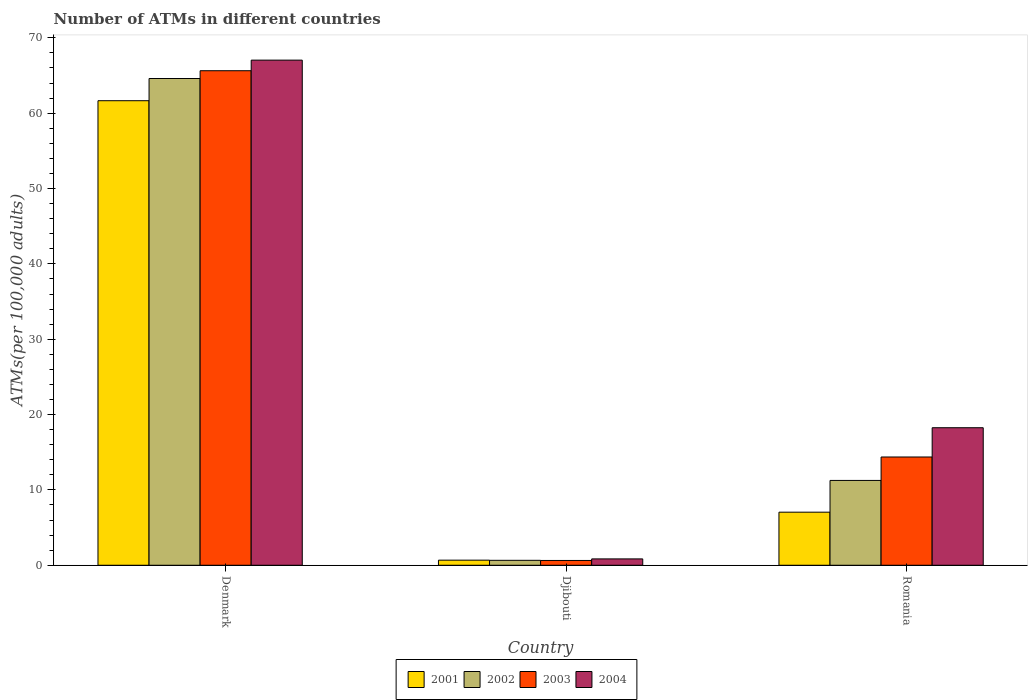Are the number of bars per tick equal to the number of legend labels?
Offer a terse response. Yes. How many bars are there on the 1st tick from the left?
Provide a succinct answer. 4. In how many cases, is the number of bars for a given country not equal to the number of legend labels?
Provide a succinct answer. 0. What is the number of ATMs in 2001 in Romania?
Offer a terse response. 7.04. Across all countries, what is the maximum number of ATMs in 2002?
Keep it short and to the point. 64.61. Across all countries, what is the minimum number of ATMs in 2004?
Give a very brief answer. 0.84. In which country was the number of ATMs in 2002 minimum?
Your answer should be very brief. Djibouti. What is the total number of ATMs in 2004 in the graph?
Give a very brief answer. 86.14. What is the difference between the number of ATMs in 2004 in Denmark and that in Romania?
Ensure brevity in your answer.  48.79. What is the difference between the number of ATMs in 2002 in Djibouti and the number of ATMs in 2001 in Denmark?
Provide a succinct answer. -61. What is the average number of ATMs in 2001 per country?
Your answer should be compact. 23.13. What is the difference between the number of ATMs of/in 2004 and number of ATMs of/in 2002 in Romania?
Offer a terse response. 7. In how many countries, is the number of ATMs in 2001 greater than 24?
Your response must be concise. 1. What is the ratio of the number of ATMs in 2002 in Djibouti to that in Romania?
Your response must be concise. 0.06. Is the number of ATMs in 2002 in Denmark less than that in Romania?
Keep it short and to the point. No. Is the difference between the number of ATMs in 2004 in Denmark and Djibouti greater than the difference between the number of ATMs in 2002 in Denmark and Djibouti?
Offer a terse response. Yes. What is the difference between the highest and the second highest number of ATMs in 2001?
Provide a succinct answer. -60.98. What is the difference between the highest and the lowest number of ATMs in 2002?
Ensure brevity in your answer.  63.95. In how many countries, is the number of ATMs in 2004 greater than the average number of ATMs in 2004 taken over all countries?
Ensure brevity in your answer.  1. Is the sum of the number of ATMs in 2001 in Djibouti and Romania greater than the maximum number of ATMs in 2004 across all countries?
Ensure brevity in your answer.  No. Is it the case that in every country, the sum of the number of ATMs in 2003 and number of ATMs in 2004 is greater than the number of ATMs in 2002?
Ensure brevity in your answer.  Yes. How many bars are there?
Your answer should be compact. 12. Are all the bars in the graph horizontal?
Keep it short and to the point. No. Does the graph contain grids?
Offer a terse response. No. How many legend labels are there?
Offer a terse response. 4. How are the legend labels stacked?
Make the answer very short. Horizontal. What is the title of the graph?
Your answer should be very brief. Number of ATMs in different countries. What is the label or title of the X-axis?
Keep it short and to the point. Country. What is the label or title of the Y-axis?
Your response must be concise. ATMs(per 100,0 adults). What is the ATMs(per 100,000 adults) of 2001 in Denmark?
Your answer should be very brief. 61.66. What is the ATMs(per 100,000 adults) in 2002 in Denmark?
Provide a succinct answer. 64.61. What is the ATMs(per 100,000 adults) of 2003 in Denmark?
Give a very brief answer. 65.64. What is the ATMs(per 100,000 adults) in 2004 in Denmark?
Give a very brief answer. 67.04. What is the ATMs(per 100,000 adults) of 2001 in Djibouti?
Your answer should be very brief. 0.68. What is the ATMs(per 100,000 adults) of 2002 in Djibouti?
Provide a succinct answer. 0.66. What is the ATMs(per 100,000 adults) in 2003 in Djibouti?
Keep it short and to the point. 0.64. What is the ATMs(per 100,000 adults) of 2004 in Djibouti?
Provide a succinct answer. 0.84. What is the ATMs(per 100,000 adults) of 2001 in Romania?
Provide a short and direct response. 7.04. What is the ATMs(per 100,000 adults) in 2002 in Romania?
Ensure brevity in your answer.  11.26. What is the ATMs(per 100,000 adults) of 2003 in Romania?
Your response must be concise. 14.37. What is the ATMs(per 100,000 adults) in 2004 in Romania?
Ensure brevity in your answer.  18.26. Across all countries, what is the maximum ATMs(per 100,000 adults) in 2001?
Your response must be concise. 61.66. Across all countries, what is the maximum ATMs(per 100,000 adults) of 2002?
Ensure brevity in your answer.  64.61. Across all countries, what is the maximum ATMs(per 100,000 adults) in 2003?
Make the answer very short. 65.64. Across all countries, what is the maximum ATMs(per 100,000 adults) of 2004?
Keep it short and to the point. 67.04. Across all countries, what is the minimum ATMs(per 100,000 adults) in 2001?
Offer a very short reply. 0.68. Across all countries, what is the minimum ATMs(per 100,000 adults) in 2002?
Provide a short and direct response. 0.66. Across all countries, what is the minimum ATMs(per 100,000 adults) in 2003?
Give a very brief answer. 0.64. Across all countries, what is the minimum ATMs(per 100,000 adults) in 2004?
Ensure brevity in your answer.  0.84. What is the total ATMs(per 100,000 adults) of 2001 in the graph?
Provide a succinct answer. 69.38. What is the total ATMs(per 100,000 adults) of 2002 in the graph?
Offer a very short reply. 76.52. What is the total ATMs(per 100,000 adults) in 2003 in the graph?
Make the answer very short. 80.65. What is the total ATMs(per 100,000 adults) in 2004 in the graph?
Provide a succinct answer. 86.14. What is the difference between the ATMs(per 100,000 adults) of 2001 in Denmark and that in Djibouti?
Offer a terse response. 60.98. What is the difference between the ATMs(per 100,000 adults) of 2002 in Denmark and that in Djibouti?
Offer a terse response. 63.95. What is the difference between the ATMs(per 100,000 adults) of 2003 in Denmark and that in Djibouti?
Give a very brief answer. 65. What is the difference between the ATMs(per 100,000 adults) in 2004 in Denmark and that in Djibouti?
Offer a terse response. 66.2. What is the difference between the ATMs(per 100,000 adults) of 2001 in Denmark and that in Romania?
Give a very brief answer. 54.61. What is the difference between the ATMs(per 100,000 adults) in 2002 in Denmark and that in Romania?
Give a very brief answer. 53.35. What is the difference between the ATMs(per 100,000 adults) in 2003 in Denmark and that in Romania?
Provide a short and direct response. 51.27. What is the difference between the ATMs(per 100,000 adults) of 2004 in Denmark and that in Romania?
Ensure brevity in your answer.  48.79. What is the difference between the ATMs(per 100,000 adults) of 2001 in Djibouti and that in Romania?
Give a very brief answer. -6.37. What is the difference between the ATMs(per 100,000 adults) of 2002 in Djibouti and that in Romania?
Provide a succinct answer. -10.6. What is the difference between the ATMs(per 100,000 adults) in 2003 in Djibouti and that in Romania?
Provide a succinct answer. -13.73. What is the difference between the ATMs(per 100,000 adults) of 2004 in Djibouti and that in Romania?
Your answer should be compact. -17.41. What is the difference between the ATMs(per 100,000 adults) in 2001 in Denmark and the ATMs(per 100,000 adults) in 2002 in Djibouti?
Your answer should be very brief. 61. What is the difference between the ATMs(per 100,000 adults) in 2001 in Denmark and the ATMs(per 100,000 adults) in 2003 in Djibouti?
Provide a short and direct response. 61.02. What is the difference between the ATMs(per 100,000 adults) in 2001 in Denmark and the ATMs(per 100,000 adults) in 2004 in Djibouti?
Provide a succinct answer. 60.81. What is the difference between the ATMs(per 100,000 adults) in 2002 in Denmark and the ATMs(per 100,000 adults) in 2003 in Djibouti?
Your answer should be very brief. 63.97. What is the difference between the ATMs(per 100,000 adults) of 2002 in Denmark and the ATMs(per 100,000 adults) of 2004 in Djibouti?
Offer a terse response. 63.76. What is the difference between the ATMs(per 100,000 adults) of 2003 in Denmark and the ATMs(per 100,000 adults) of 2004 in Djibouti?
Provide a succinct answer. 64.79. What is the difference between the ATMs(per 100,000 adults) of 2001 in Denmark and the ATMs(per 100,000 adults) of 2002 in Romania?
Your response must be concise. 50.4. What is the difference between the ATMs(per 100,000 adults) in 2001 in Denmark and the ATMs(per 100,000 adults) in 2003 in Romania?
Keep it short and to the point. 47.29. What is the difference between the ATMs(per 100,000 adults) in 2001 in Denmark and the ATMs(per 100,000 adults) in 2004 in Romania?
Make the answer very short. 43.4. What is the difference between the ATMs(per 100,000 adults) of 2002 in Denmark and the ATMs(per 100,000 adults) of 2003 in Romania?
Your response must be concise. 50.24. What is the difference between the ATMs(per 100,000 adults) in 2002 in Denmark and the ATMs(per 100,000 adults) in 2004 in Romania?
Provide a short and direct response. 46.35. What is the difference between the ATMs(per 100,000 adults) in 2003 in Denmark and the ATMs(per 100,000 adults) in 2004 in Romania?
Provide a short and direct response. 47.38. What is the difference between the ATMs(per 100,000 adults) of 2001 in Djibouti and the ATMs(per 100,000 adults) of 2002 in Romania?
Provide a succinct answer. -10.58. What is the difference between the ATMs(per 100,000 adults) in 2001 in Djibouti and the ATMs(per 100,000 adults) in 2003 in Romania?
Offer a terse response. -13.69. What is the difference between the ATMs(per 100,000 adults) in 2001 in Djibouti and the ATMs(per 100,000 adults) in 2004 in Romania?
Ensure brevity in your answer.  -17.58. What is the difference between the ATMs(per 100,000 adults) of 2002 in Djibouti and the ATMs(per 100,000 adults) of 2003 in Romania?
Keep it short and to the point. -13.71. What is the difference between the ATMs(per 100,000 adults) of 2002 in Djibouti and the ATMs(per 100,000 adults) of 2004 in Romania?
Give a very brief answer. -17.6. What is the difference between the ATMs(per 100,000 adults) of 2003 in Djibouti and the ATMs(per 100,000 adults) of 2004 in Romania?
Provide a succinct answer. -17.62. What is the average ATMs(per 100,000 adults) in 2001 per country?
Offer a very short reply. 23.13. What is the average ATMs(per 100,000 adults) in 2002 per country?
Offer a very short reply. 25.51. What is the average ATMs(per 100,000 adults) of 2003 per country?
Your response must be concise. 26.88. What is the average ATMs(per 100,000 adults) in 2004 per country?
Your response must be concise. 28.71. What is the difference between the ATMs(per 100,000 adults) of 2001 and ATMs(per 100,000 adults) of 2002 in Denmark?
Provide a succinct answer. -2.95. What is the difference between the ATMs(per 100,000 adults) of 2001 and ATMs(per 100,000 adults) of 2003 in Denmark?
Give a very brief answer. -3.98. What is the difference between the ATMs(per 100,000 adults) of 2001 and ATMs(per 100,000 adults) of 2004 in Denmark?
Your response must be concise. -5.39. What is the difference between the ATMs(per 100,000 adults) in 2002 and ATMs(per 100,000 adults) in 2003 in Denmark?
Make the answer very short. -1.03. What is the difference between the ATMs(per 100,000 adults) in 2002 and ATMs(per 100,000 adults) in 2004 in Denmark?
Offer a terse response. -2.44. What is the difference between the ATMs(per 100,000 adults) in 2003 and ATMs(per 100,000 adults) in 2004 in Denmark?
Offer a terse response. -1.41. What is the difference between the ATMs(per 100,000 adults) in 2001 and ATMs(per 100,000 adults) in 2002 in Djibouti?
Provide a succinct answer. 0.02. What is the difference between the ATMs(per 100,000 adults) in 2001 and ATMs(per 100,000 adults) in 2003 in Djibouti?
Your response must be concise. 0.04. What is the difference between the ATMs(per 100,000 adults) in 2001 and ATMs(per 100,000 adults) in 2004 in Djibouti?
Your answer should be compact. -0.17. What is the difference between the ATMs(per 100,000 adults) of 2002 and ATMs(per 100,000 adults) of 2003 in Djibouti?
Give a very brief answer. 0.02. What is the difference between the ATMs(per 100,000 adults) of 2002 and ATMs(per 100,000 adults) of 2004 in Djibouti?
Offer a very short reply. -0.19. What is the difference between the ATMs(per 100,000 adults) of 2003 and ATMs(per 100,000 adults) of 2004 in Djibouti?
Provide a short and direct response. -0.21. What is the difference between the ATMs(per 100,000 adults) in 2001 and ATMs(per 100,000 adults) in 2002 in Romania?
Give a very brief answer. -4.21. What is the difference between the ATMs(per 100,000 adults) in 2001 and ATMs(per 100,000 adults) in 2003 in Romania?
Give a very brief answer. -7.32. What is the difference between the ATMs(per 100,000 adults) in 2001 and ATMs(per 100,000 adults) in 2004 in Romania?
Your response must be concise. -11.21. What is the difference between the ATMs(per 100,000 adults) of 2002 and ATMs(per 100,000 adults) of 2003 in Romania?
Give a very brief answer. -3.11. What is the difference between the ATMs(per 100,000 adults) of 2002 and ATMs(per 100,000 adults) of 2004 in Romania?
Your answer should be compact. -7. What is the difference between the ATMs(per 100,000 adults) of 2003 and ATMs(per 100,000 adults) of 2004 in Romania?
Your response must be concise. -3.89. What is the ratio of the ATMs(per 100,000 adults) of 2001 in Denmark to that in Djibouti?
Your response must be concise. 91.18. What is the ratio of the ATMs(per 100,000 adults) in 2002 in Denmark to that in Djibouti?
Ensure brevity in your answer.  98.45. What is the ratio of the ATMs(per 100,000 adults) in 2003 in Denmark to that in Djibouti?
Provide a succinct answer. 102.88. What is the ratio of the ATMs(per 100,000 adults) of 2004 in Denmark to that in Djibouti?
Offer a very short reply. 79.46. What is the ratio of the ATMs(per 100,000 adults) of 2001 in Denmark to that in Romania?
Your answer should be very brief. 8.75. What is the ratio of the ATMs(per 100,000 adults) of 2002 in Denmark to that in Romania?
Provide a short and direct response. 5.74. What is the ratio of the ATMs(per 100,000 adults) in 2003 in Denmark to that in Romania?
Your response must be concise. 4.57. What is the ratio of the ATMs(per 100,000 adults) in 2004 in Denmark to that in Romania?
Your response must be concise. 3.67. What is the ratio of the ATMs(per 100,000 adults) of 2001 in Djibouti to that in Romania?
Offer a terse response. 0.1. What is the ratio of the ATMs(per 100,000 adults) in 2002 in Djibouti to that in Romania?
Give a very brief answer. 0.06. What is the ratio of the ATMs(per 100,000 adults) in 2003 in Djibouti to that in Romania?
Make the answer very short. 0.04. What is the ratio of the ATMs(per 100,000 adults) in 2004 in Djibouti to that in Romania?
Offer a very short reply. 0.05. What is the difference between the highest and the second highest ATMs(per 100,000 adults) in 2001?
Keep it short and to the point. 54.61. What is the difference between the highest and the second highest ATMs(per 100,000 adults) of 2002?
Your response must be concise. 53.35. What is the difference between the highest and the second highest ATMs(per 100,000 adults) of 2003?
Your answer should be very brief. 51.27. What is the difference between the highest and the second highest ATMs(per 100,000 adults) in 2004?
Provide a short and direct response. 48.79. What is the difference between the highest and the lowest ATMs(per 100,000 adults) of 2001?
Give a very brief answer. 60.98. What is the difference between the highest and the lowest ATMs(per 100,000 adults) in 2002?
Your response must be concise. 63.95. What is the difference between the highest and the lowest ATMs(per 100,000 adults) of 2003?
Ensure brevity in your answer.  65. What is the difference between the highest and the lowest ATMs(per 100,000 adults) in 2004?
Provide a succinct answer. 66.2. 